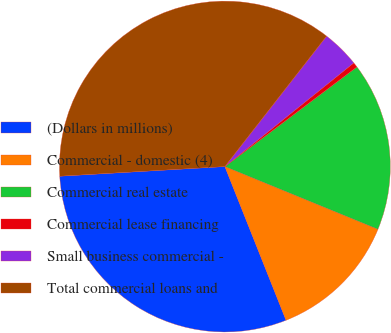<chart> <loc_0><loc_0><loc_500><loc_500><pie_chart><fcel>(Dollars in millions)<fcel>Commercial - domestic (4)<fcel>Commercial real estate<fcel>Commercial lease financing<fcel>Small business commercial -<fcel>Total commercial loans and<nl><fcel>30.1%<fcel>12.78%<fcel>16.48%<fcel>0.49%<fcel>3.68%<fcel>36.47%<nl></chart> 